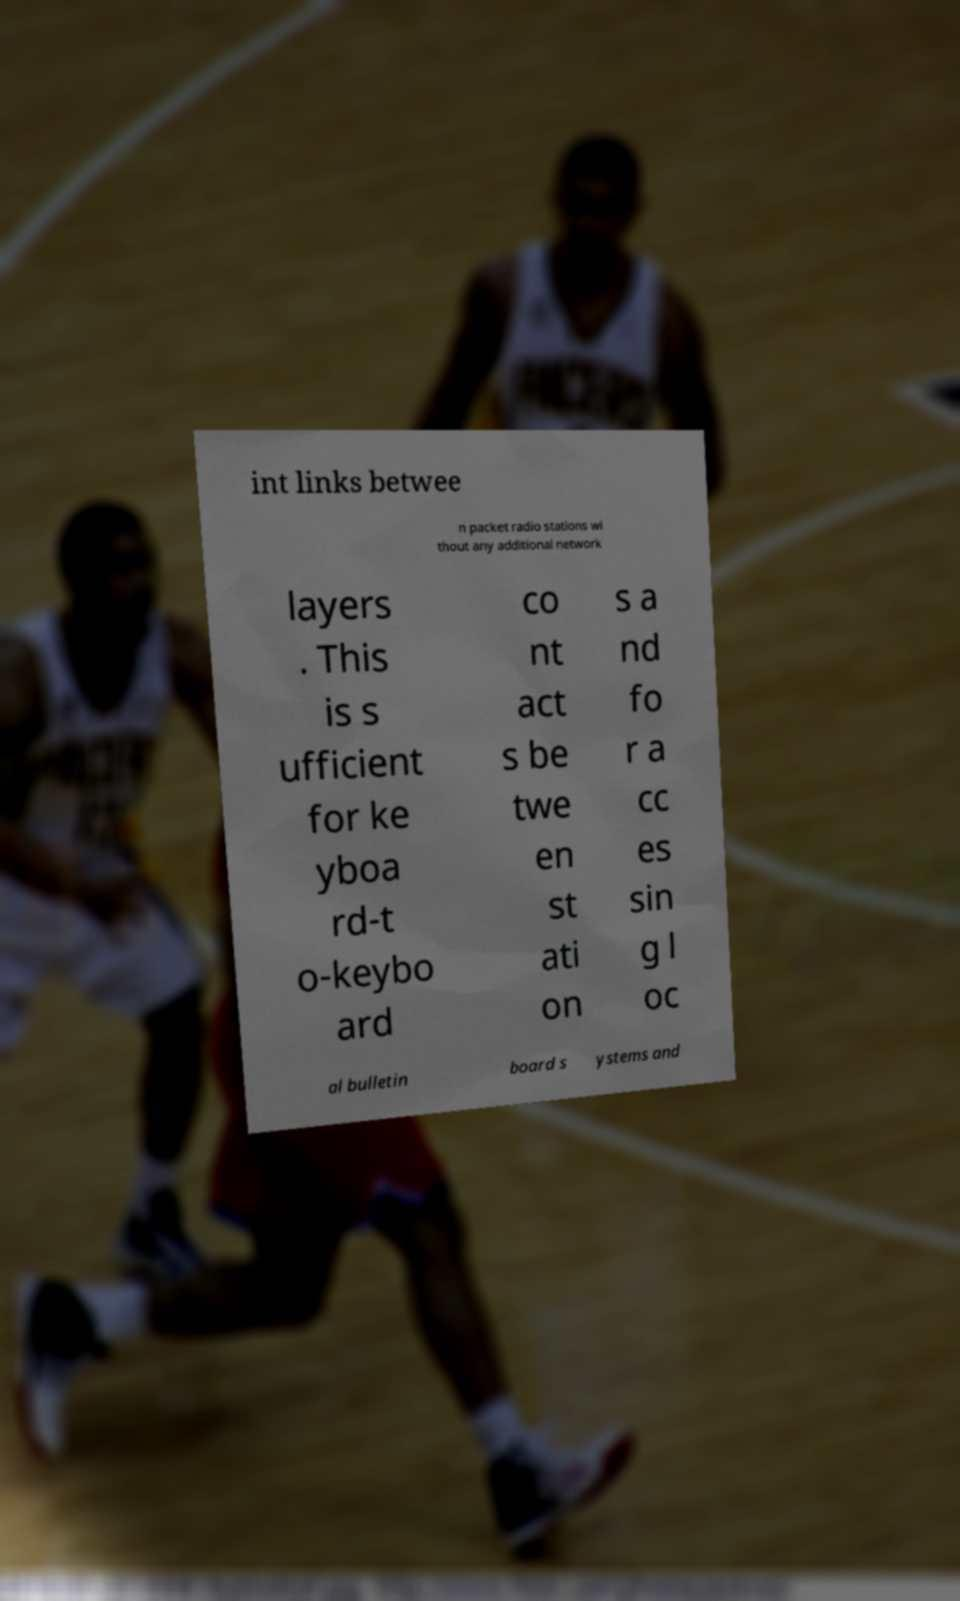What messages or text are displayed in this image? I need them in a readable, typed format. int links betwee n packet radio stations wi thout any additional network layers . This is s ufficient for ke yboa rd-t o-keybo ard co nt act s be twe en st ati on s a nd fo r a cc es sin g l oc al bulletin board s ystems and 